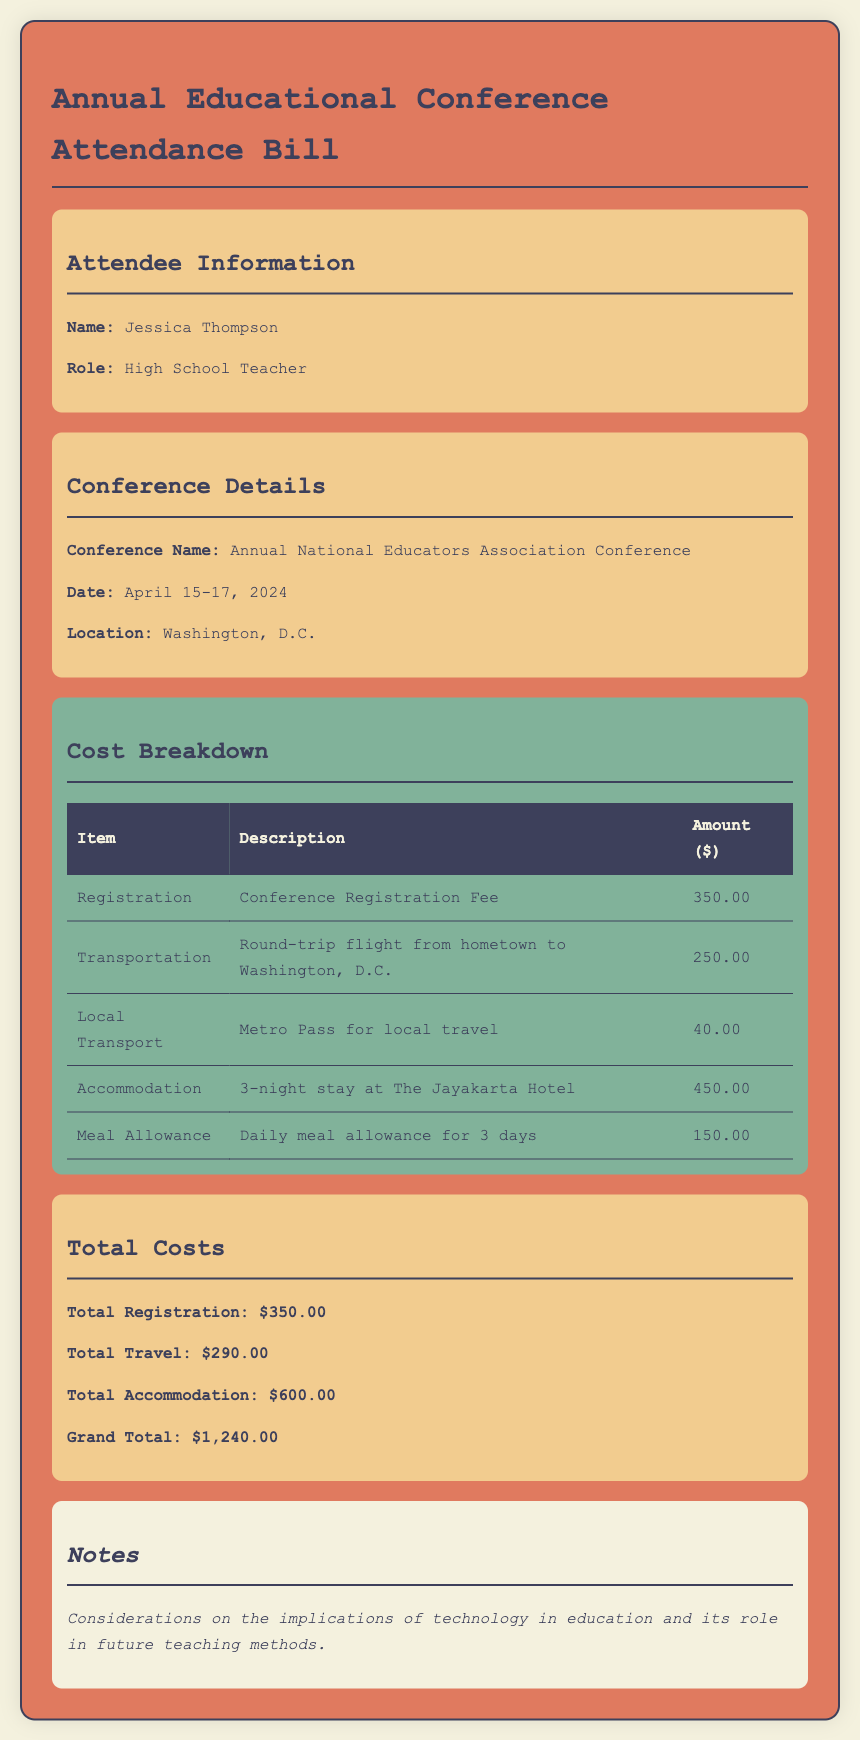What is the name of the attendee? The document lists Jessica Thompson as the attendee.
Answer: Jessica Thompson What is the conference location? The conference is set to be held in Washington, D.C.
Answer: Washington, D.C How much is the registration fee? The registration fee mentioned is $350.00.
Answer: $350.00 What is the total amount for accommodation? The total for accommodation is given as $600.00.
Answer: $600.00 What is the grand total cost for the conference? The grand total cost combines all items and is stated as $1,240.00.
Answer: $1,240.00 How many nights will the attendee stay at the hotel? The document specifies a 3-night stay at the hotel.
Answer: 3 nights Which transportation method is used for local travel? The document mentions using a Metro Pass for local transport.
Answer: Metro Pass What does the meal allowance cover? The meal allowance covers daily meals for 3 days.
Answer: Daily meal allowance for 3 days What is one consideration listed in the notes? The notes mention implications of technology in education as a consideration.
Answer: Implications of technology in education 